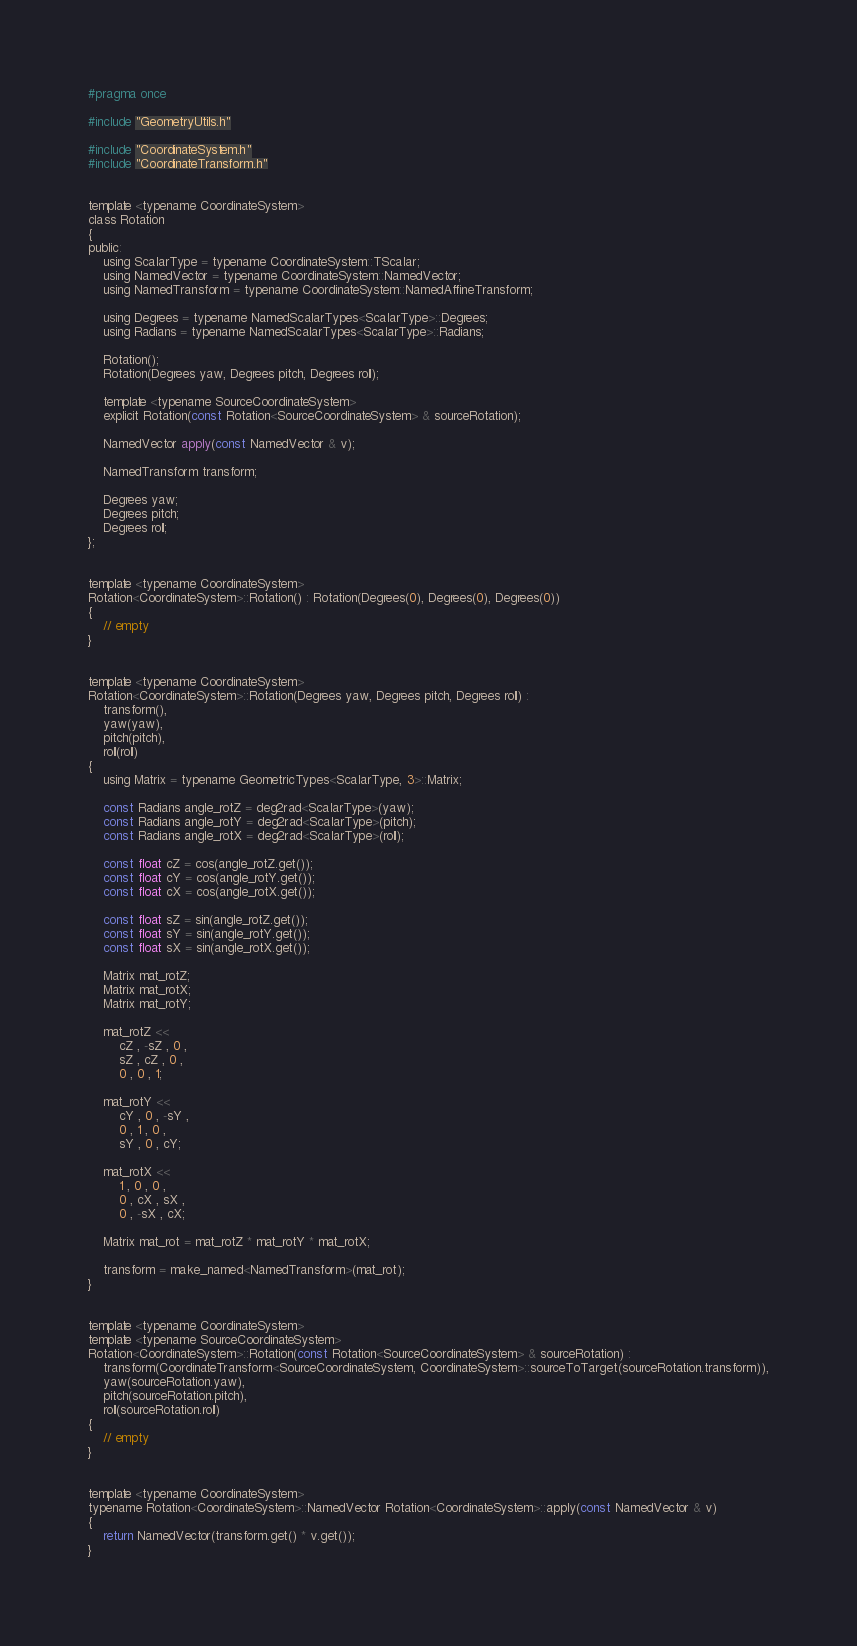<code> <loc_0><loc_0><loc_500><loc_500><_C_>#pragma once

#include "GeometryUtils.h"

#include "CoordinateSystem.h"
#include "CoordinateTransform.h"


template <typename CoordinateSystem>
class Rotation
{
public:
	using ScalarType = typename CoordinateSystem::TScalar;
	using NamedVector = typename CoordinateSystem::NamedVector;
	using NamedTransform = typename CoordinateSystem::NamedAffineTransform;

	using Degrees = typename NamedScalarTypes<ScalarType>::Degrees;
	using Radians = typename NamedScalarTypes<ScalarType>::Radians;

	Rotation();
	Rotation(Degrees yaw, Degrees pitch, Degrees roll);

	template <typename SourceCoordinateSystem>
	explicit Rotation(const Rotation<SourceCoordinateSystem> & sourceRotation);

	NamedVector apply(const NamedVector & v);

	NamedTransform transform;

	Degrees yaw;
	Degrees pitch;
	Degrees roll;
};


template <typename CoordinateSystem>
Rotation<CoordinateSystem>::Rotation() : Rotation(Degrees(0), Degrees(0), Degrees(0))
{
	// empty
}


template <typename CoordinateSystem>
Rotation<CoordinateSystem>::Rotation(Degrees yaw, Degrees pitch, Degrees roll) :
	transform(),
	yaw(yaw),
	pitch(pitch),
	roll(roll)
{
	using Matrix = typename GeometricTypes<ScalarType, 3>::Matrix;

	const Radians angle_rotZ = deg2rad<ScalarType>(yaw);
	const Radians angle_rotY = deg2rad<ScalarType>(pitch);
	const Radians angle_rotX = deg2rad<ScalarType>(roll);

	const float cZ = cos(angle_rotZ.get());
	const float cY = cos(angle_rotY.get());
	const float cX = cos(angle_rotX.get());

	const float sZ = sin(angle_rotZ.get());
	const float sY = sin(angle_rotY.get());
	const float sX = sin(angle_rotX.get());

	Matrix mat_rotZ;
	Matrix mat_rotX;
	Matrix mat_rotY;

	mat_rotZ <<
		cZ , -sZ , 0 ,
		sZ , cZ , 0 ,
		0 , 0 , 1;

	mat_rotY <<
		cY , 0 , -sY ,
		0 , 1 , 0 ,
		sY , 0 , cY;

	mat_rotX <<
		1 , 0 , 0 ,
		0 , cX , sX ,
		0 , -sX , cX;

	Matrix mat_rot = mat_rotZ * mat_rotY * mat_rotX;

	transform = make_named<NamedTransform>(mat_rot);
}


template <typename CoordinateSystem>
template <typename SourceCoordinateSystem>
Rotation<CoordinateSystem>::Rotation(const Rotation<SourceCoordinateSystem> & sourceRotation) :
	transform(CoordinateTransform<SourceCoordinateSystem, CoordinateSystem>::sourceToTarget(sourceRotation.transform)),
	yaw(sourceRotation.yaw),
	pitch(sourceRotation.pitch),
	roll(sourceRotation.roll)
{
	// empty
}


template <typename CoordinateSystem>
typename Rotation<CoordinateSystem>::NamedVector Rotation<CoordinateSystem>::apply(const NamedVector & v)
{
	return NamedVector(transform.get() * v.get());
}
</code> 